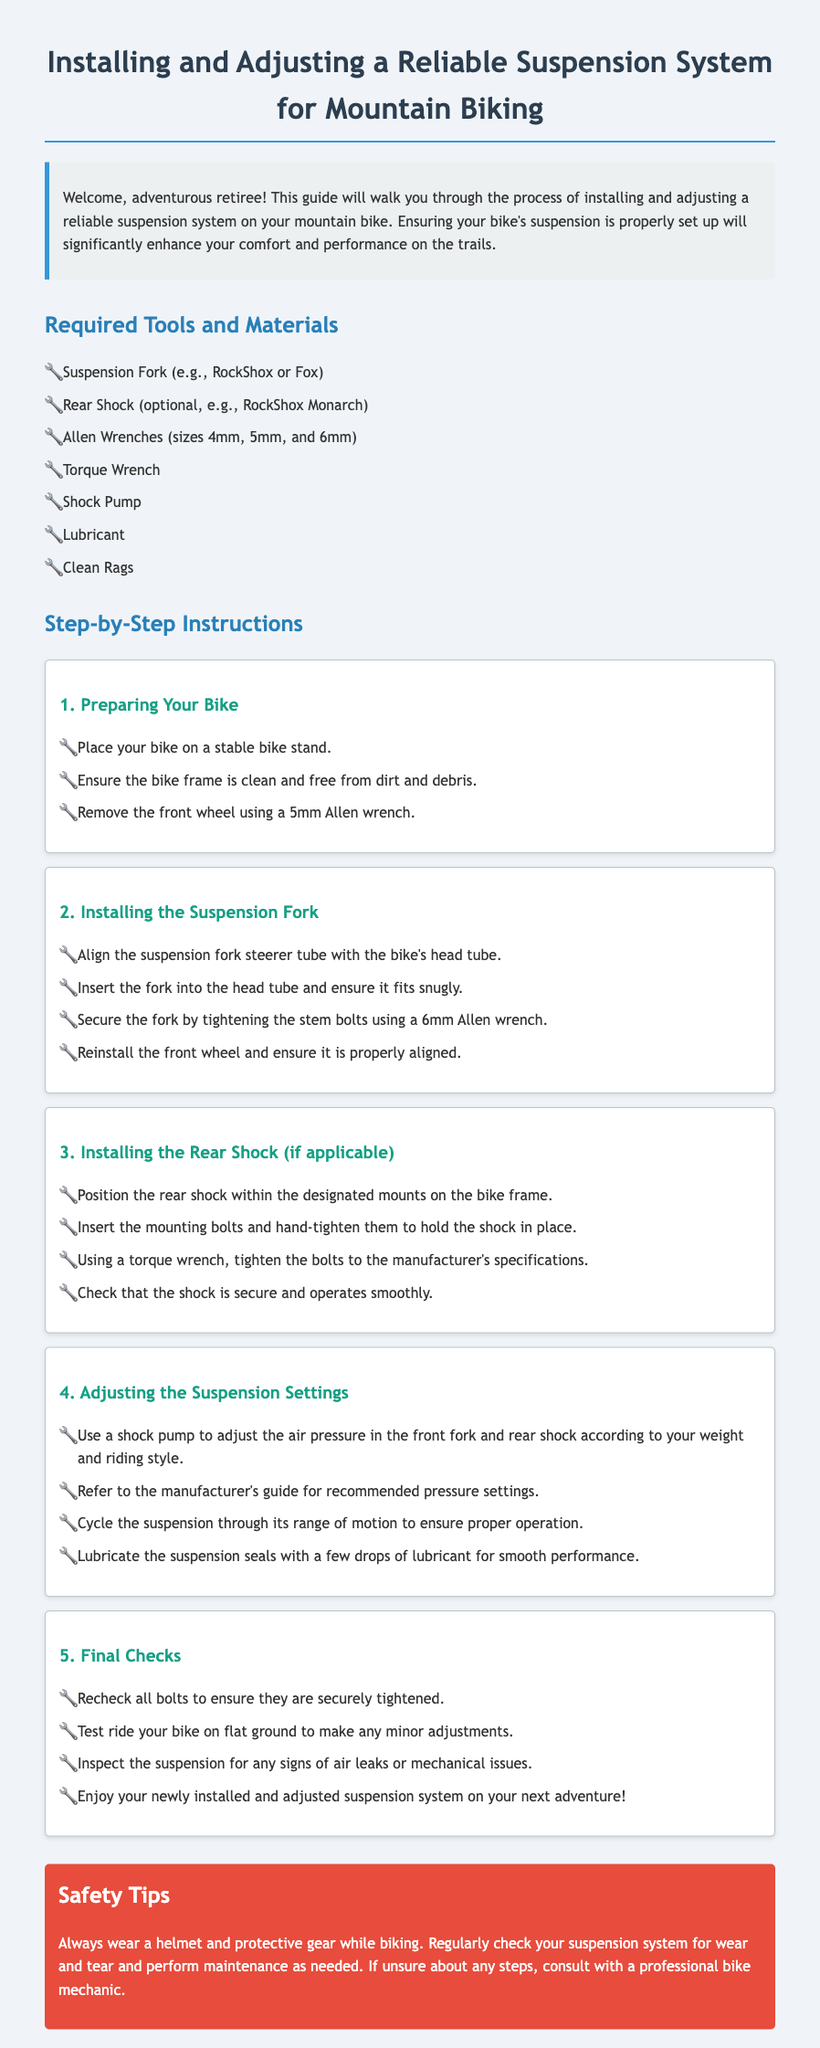What tools are required for installation? The document lists the tools needed for the installation process, which include suspension fork, rear shock, Allen wrenches, torque wrench, shock pump, lubricant, and clean rags.
Answer: Suspension fork, rear shock, Allen wrenches, torque wrench, shock pump, lubricant, clean rags How many steps are there in the installation process? The document outlines a total of five main steps for the installation and adjustment of the suspension system.
Answer: 5 What size Allen wrench is needed to remove the front wheel? The document specifically mentions a 5mm Allen wrench for removing the front wheel.
Answer: 5mm What should you do after installing the suspension system? According to the instructions, you should test ride your bike on flat ground to make any minor adjustments after installation.
Answer: Test ride What is a recommended action before starting the installation? The document suggests placing the bike on a stable bike stand before proceeding with the installation.
Answer: Place on stable bike stand What type of shock is optional for installation? The document mentions the RockShox Monarch as an optional rear shock for installation.
Answer: RockShox Monarch What should you check after tightening all bolts? After tightening all bolts, you should inspect the suspension for any signs of air leaks or mechanical issues.
Answer: Inspect for air leaks or mechanical issues What is advised to use for smooth performance of the suspension? The instructions indicate lubricating the suspension seals with a few drops of lubricant for smooth performance.
Answer: Lubricant 